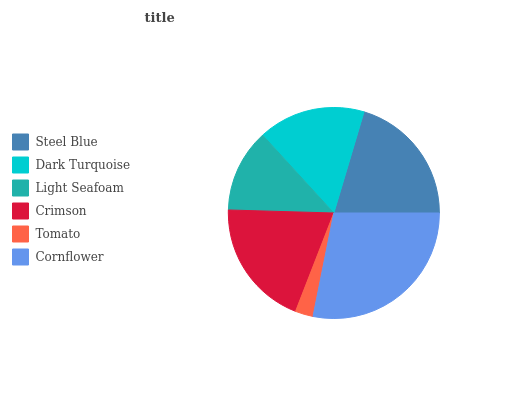Is Tomato the minimum?
Answer yes or no. Yes. Is Cornflower the maximum?
Answer yes or no. Yes. Is Dark Turquoise the minimum?
Answer yes or no. No. Is Dark Turquoise the maximum?
Answer yes or no. No. Is Steel Blue greater than Dark Turquoise?
Answer yes or no. Yes. Is Dark Turquoise less than Steel Blue?
Answer yes or no. Yes. Is Dark Turquoise greater than Steel Blue?
Answer yes or no. No. Is Steel Blue less than Dark Turquoise?
Answer yes or no. No. Is Crimson the high median?
Answer yes or no. Yes. Is Dark Turquoise the low median?
Answer yes or no. Yes. Is Light Seafoam the high median?
Answer yes or no. No. Is Tomato the low median?
Answer yes or no. No. 